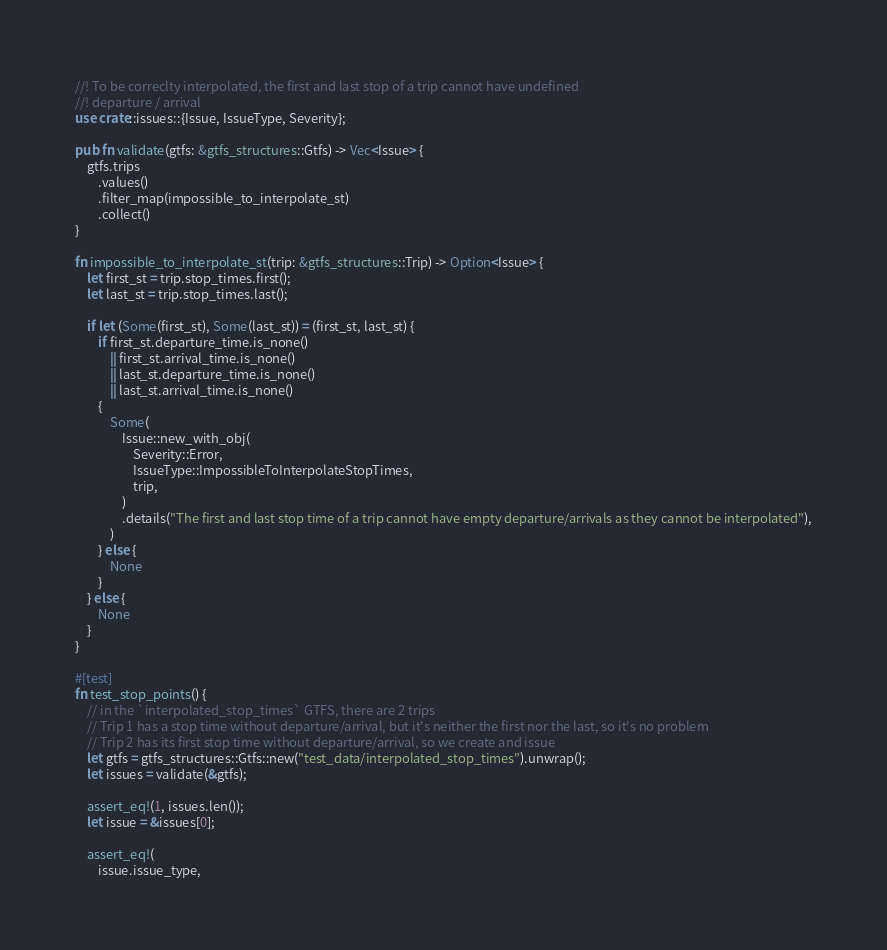<code> <loc_0><loc_0><loc_500><loc_500><_Rust_>//! To be correclty interpolated, the first and last stop of a trip cannot have undefined
//! departure / arrival
use crate::issues::{Issue, IssueType, Severity};

pub fn validate(gtfs: &gtfs_structures::Gtfs) -> Vec<Issue> {
    gtfs.trips
        .values()
        .filter_map(impossible_to_interpolate_st)
        .collect()
}

fn impossible_to_interpolate_st(trip: &gtfs_structures::Trip) -> Option<Issue> {
    let first_st = trip.stop_times.first();
    let last_st = trip.stop_times.last();

    if let (Some(first_st), Some(last_st)) = (first_st, last_st) {
        if first_st.departure_time.is_none()
            || first_st.arrival_time.is_none()
            || last_st.departure_time.is_none()
            || last_st.arrival_time.is_none()
        {
            Some(
                Issue::new_with_obj(
                    Severity::Error,
                    IssueType::ImpossibleToInterpolateStopTimes,
                    trip,
                )
                .details("The first and last stop time of a trip cannot have empty departure/arrivals as they cannot be interpolated"),
            )
        } else {
            None
        }
    } else {
        None
    }
}

#[test]
fn test_stop_points() {
    // in the `interpolated_stop_times` GTFS, there are 2 trips
    // Trip 1 has a stop time without departure/arrival, but it's neither the first nor the last, so it's no problem
    // Trip 2 has its first stop time without departure/arrival, so we create and issue
    let gtfs = gtfs_structures::Gtfs::new("test_data/interpolated_stop_times").unwrap();
    let issues = validate(&gtfs);

    assert_eq!(1, issues.len());
    let issue = &issues[0];

    assert_eq!(
        issue.issue_type,</code> 